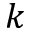Convert formula to latex. <formula><loc_0><loc_0><loc_500><loc_500>k</formula> 